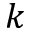Convert formula to latex. <formula><loc_0><loc_0><loc_500><loc_500>k</formula> 